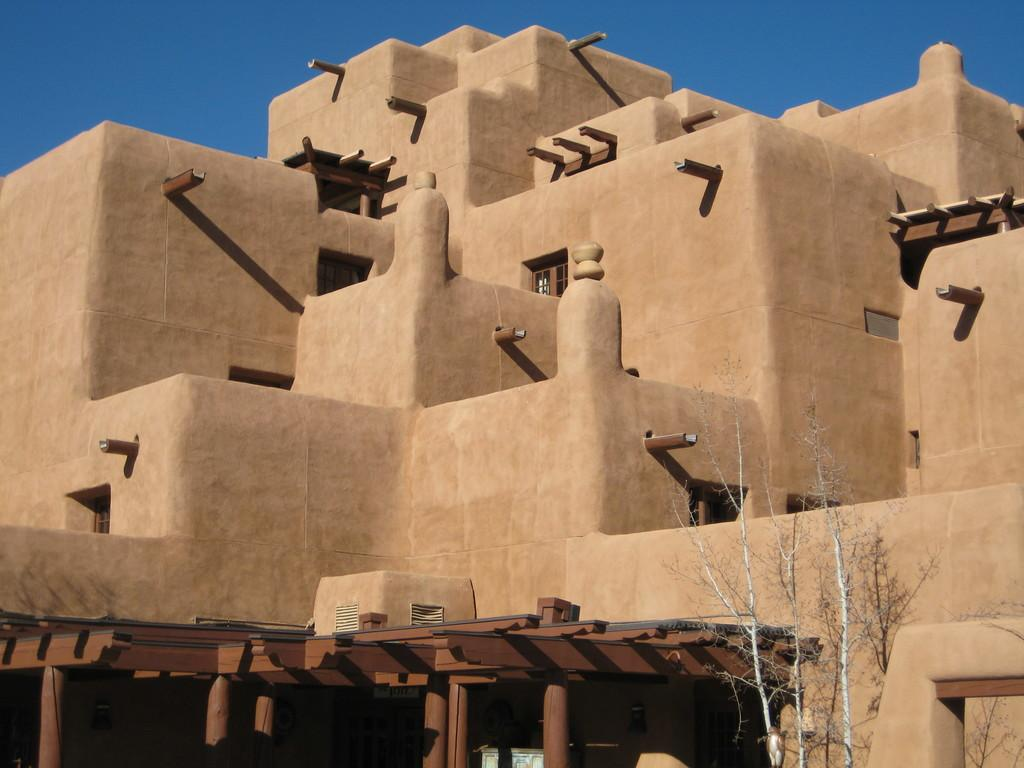What type of architecture is visible in the image? The image contains old architecture. What can be seen in the foreground of the image? There is a tree in the foreground of the image. How would you describe the weather based on the image? The sky is sunny, suggesting a clear and bright day. What type of stove can be seen in the image? There is no stove present in the image. How many teeth are visible on the tree in the image? Trees do not have teeth, so this question cannot be answered. 